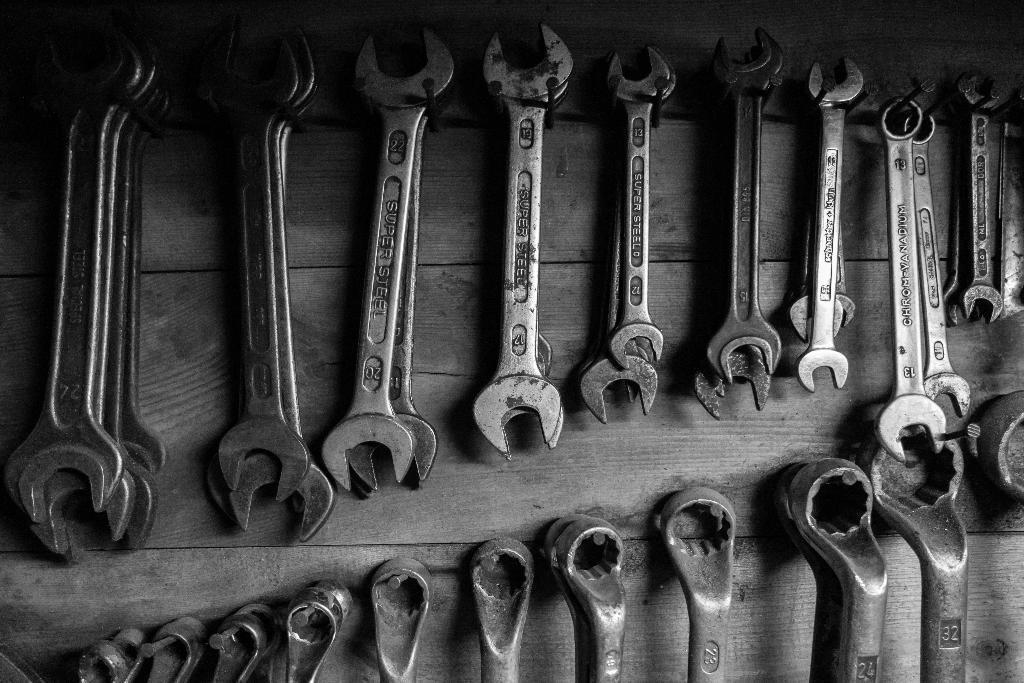In one or two sentences, can you explain what this image depicts? In this picture we can see different sizes of open end wrenches and box end wrenches here, at the bottom there is a wooden surface. 